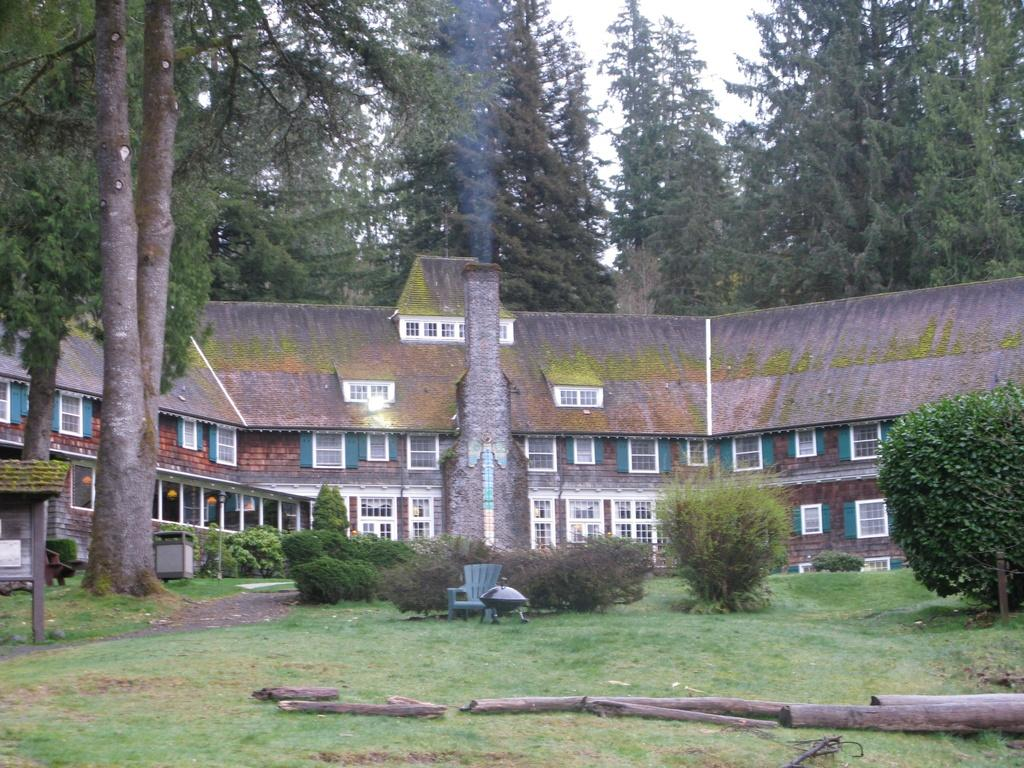What objects are located at the bottom of the image? There are logs at the bottom of the image. What piece of furniture is in the middle of the image? There is a chair in the middle of the image. What type of building can be seen at the back side of the image? There is a big house at the back side of the image. What type of vegetation is present in the image? There are trees in the image. What is visible at the top of the image? The sky is visible at the top of the image. Can you tell me the purpose of the toad in the image? There is no toad present in the image, so it is not possible to determine its purpose. What type of thing is hanging from the trees in the image? There is no thing hanging from the trees in the image; only trees and logs are present. 